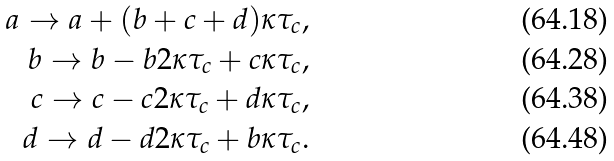Convert formula to latex. <formula><loc_0><loc_0><loc_500><loc_500>a \rightarrow a + ( b + c + d ) \kappa \tau _ { c } , \\ b \rightarrow b - b 2 \kappa \tau _ { c } + c \kappa \tau _ { c } , \\ c \rightarrow c - c 2 \kappa \tau _ { c } + d \kappa \tau _ { c } , \\ d \rightarrow d - d 2 \kappa \tau _ { c } + b \kappa \tau _ { c } .</formula> 